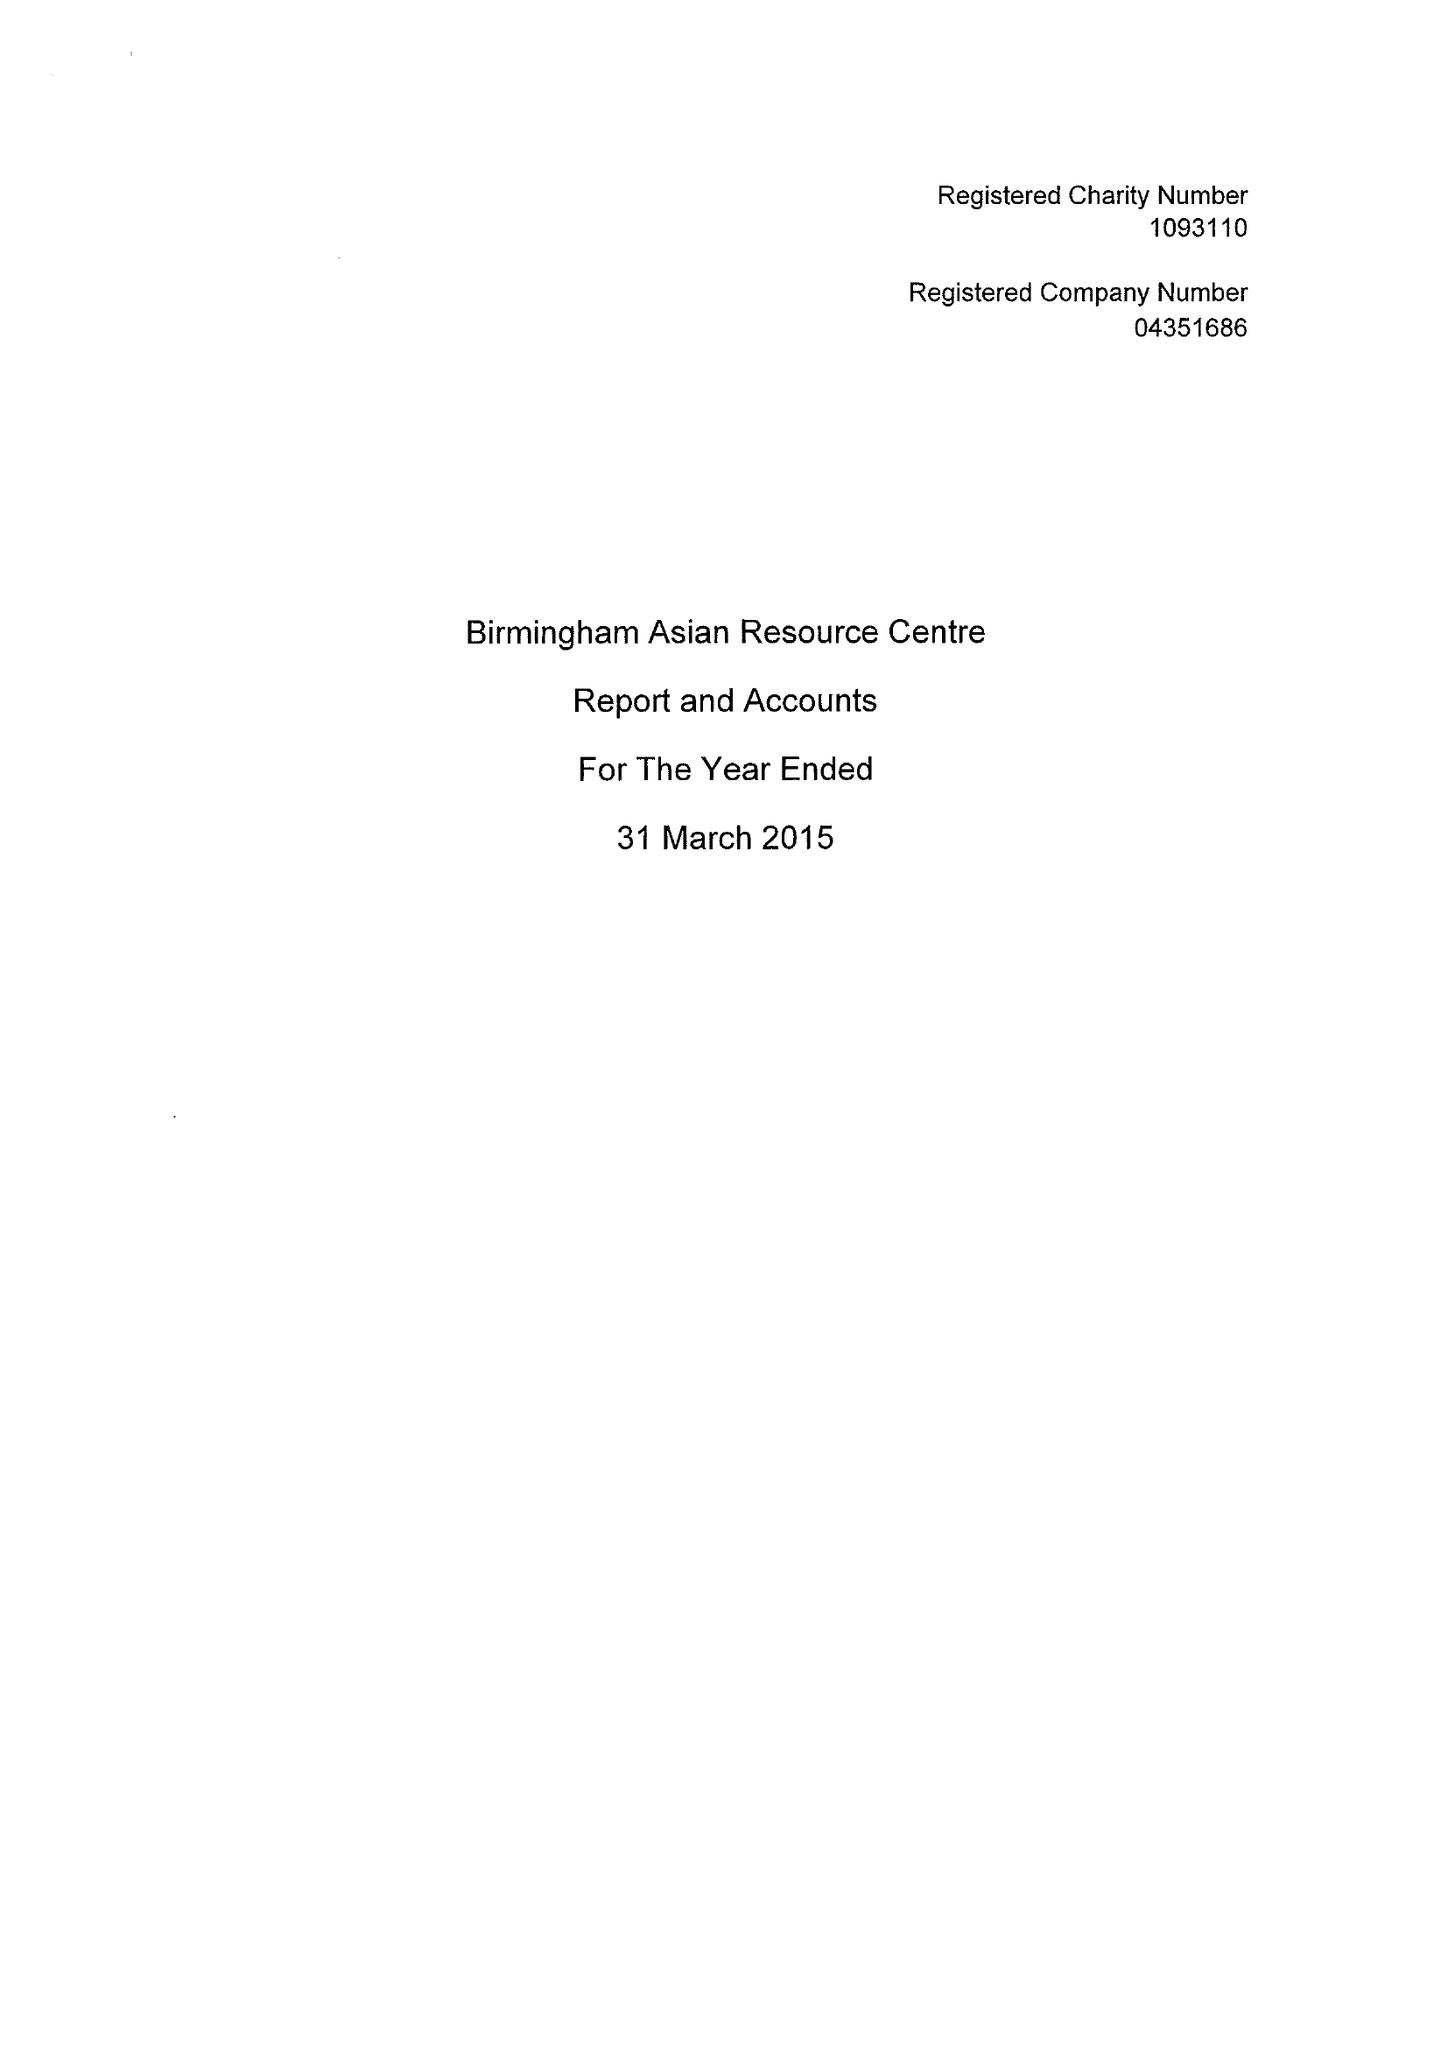What is the value for the charity_name?
Answer the question using a single word or phrase. Birmingham Asian Resource Centre 